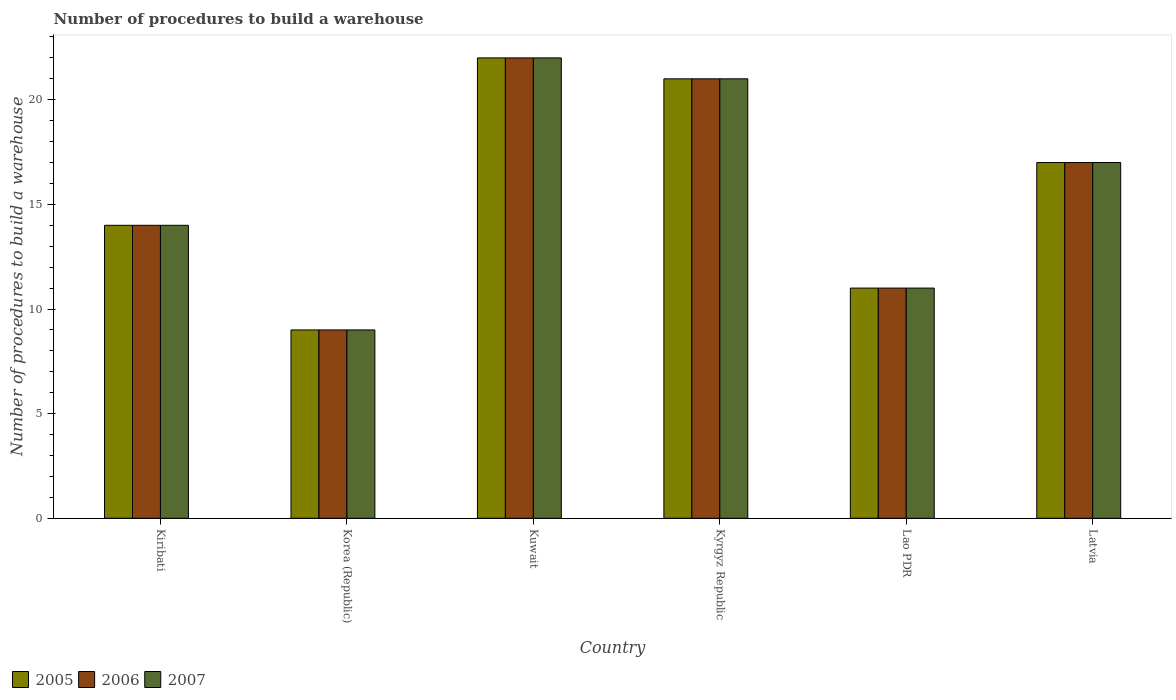Are the number of bars per tick equal to the number of legend labels?
Ensure brevity in your answer.  Yes. How many bars are there on the 6th tick from the left?
Your answer should be very brief. 3. How many bars are there on the 5th tick from the right?
Your answer should be compact. 3. What is the label of the 1st group of bars from the left?
Your answer should be very brief. Kiribati. In how many cases, is the number of bars for a given country not equal to the number of legend labels?
Make the answer very short. 0. In which country was the number of procedures to build a warehouse in in 2007 maximum?
Your response must be concise. Kuwait. What is the total number of procedures to build a warehouse in in 2007 in the graph?
Your answer should be compact. 94. What is the difference between the number of procedures to build a warehouse in in 2007 in Lao PDR and that in Latvia?
Ensure brevity in your answer.  -6. What is the average number of procedures to build a warehouse in in 2005 per country?
Offer a terse response. 15.67. In how many countries, is the number of procedures to build a warehouse in in 2006 greater than 4?
Offer a very short reply. 6. What is the ratio of the number of procedures to build a warehouse in in 2005 in Korea (Republic) to that in Latvia?
Provide a succinct answer. 0.53. Is the number of procedures to build a warehouse in in 2005 in Kuwait less than that in Kyrgyz Republic?
Provide a short and direct response. No. Is the difference between the number of procedures to build a warehouse in in 2006 in Kiribati and Latvia greater than the difference between the number of procedures to build a warehouse in in 2005 in Kiribati and Latvia?
Provide a succinct answer. No. What is the difference between the highest and the lowest number of procedures to build a warehouse in in 2005?
Your answer should be compact. 13. Is the sum of the number of procedures to build a warehouse in in 2007 in Korea (Republic) and Kyrgyz Republic greater than the maximum number of procedures to build a warehouse in in 2006 across all countries?
Your answer should be compact. Yes. What does the 1st bar from the right in Kuwait represents?
Offer a terse response. 2007. Are all the bars in the graph horizontal?
Keep it short and to the point. No. How many countries are there in the graph?
Provide a succinct answer. 6. Are the values on the major ticks of Y-axis written in scientific E-notation?
Keep it short and to the point. No. Does the graph contain any zero values?
Offer a terse response. No. What is the title of the graph?
Your answer should be compact. Number of procedures to build a warehouse. What is the label or title of the Y-axis?
Your answer should be compact. Number of procedures to build a warehouse. What is the Number of procedures to build a warehouse in 2007 in Kiribati?
Offer a very short reply. 14. What is the Number of procedures to build a warehouse in 2006 in Korea (Republic)?
Your response must be concise. 9. What is the Number of procedures to build a warehouse in 2006 in Kuwait?
Your answer should be compact. 22. What is the Number of procedures to build a warehouse in 2007 in Kuwait?
Give a very brief answer. 22. What is the Number of procedures to build a warehouse in 2005 in Kyrgyz Republic?
Keep it short and to the point. 21. What is the Number of procedures to build a warehouse in 2006 in Kyrgyz Republic?
Keep it short and to the point. 21. What is the Number of procedures to build a warehouse in 2005 in Lao PDR?
Give a very brief answer. 11. What is the Number of procedures to build a warehouse in 2005 in Latvia?
Your answer should be compact. 17. What is the Number of procedures to build a warehouse in 2006 in Latvia?
Your answer should be very brief. 17. What is the Number of procedures to build a warehouse in 2007 in Latvia?
Offer a terse response. 17. Across all countries, what is the maximum Number of procedures to build a warehouse of 2005?
Offer a very short reply. 22. Across all countries, what is the maximum Number of procedures to build a warehouse of 2006?
Your answer should be very brief. 22. Across all countries, what is the minimum Number of procedures to build a warehouse of 2005?
Offer a very short reply. 9. Across all countries, what is the minimum Number of procedures to build a warehouse in 2006?
Provide a succinct answer. 9. Across all countries, what is the minimum Number of procedures to build a warehouse of 2007?
Your answer should be very brief. 9. What is the total Number of procedures to build a warehouse in 2005 in the graph?
Provide a succinct answer. 94. What is the total Number of procedures to build a warehouse of 2006 in the graph?
Give a very brief answer. 94. What is the total Number of procedures to build a warehouse in 2007 in the graph?
Your response must be concise. 94. What is the difference between the Number of procedures to build a warehouse in 2005 in Kiribati and that in Korea (Republic)?
Your answer should be very brief. 5. What is the difference between the Number of procedures to build a warehouse in 2005 in Kiribati and that in Kuwait?
Offer a terse response. -8. What is the difference between the Number of procedures to build a warehouse in 2006 in Kiribati and that in Kuwait?
Give a very brief answer. -8. What is the difference between the Number of procedures to build a warehouse in 2007 in Kiribati and that in Kuwait?
Offer a very short reply. -8. What is the difference between the Number of procedures to build a warehouse of 2006 in Kiribati and that in Kyrgyz Republic?
Give a very brief answer. -7. What is the difference between the Number of procedures to build a warehouse of 2007 in Kiribati and that in Kyrgyz Republic?
Keep it short and to the point. -7. What is the difference between the Number of procedures to build a warehouse in 2005 in Kiribati and that in Lao PDR?
Your answer should be very brief. 3. What is the difference between the Number of procedures to build a warehouse in 2007 in Kiribati and that in Lao PDR?
Provide a succinct answer. 3. What is the difference between the Number of procedures to build a warehouse of 2005 in Kiribati and that in Latvia?
Your response must be concise. -3. What is the difference between the Number of procedures to build a warehouse of 2007 in Kiribati and that in Latvia?
Your response must be concise. -3. What is the difference between the Number of procedures to build a warehouse in 2007 in Korea (Republic) and that in Kuwait?
Provide a succinct answer. -13. What is the difference between the Number of procedures to build a warehouse of 2006 in Korea (Republic) and that in Kyrgyz Republic?
Your answer should be very brief. -12. What is the difference between the Number of procedures to build a warehouse in 2007 in Korea (Republic) and that in Kyrgyz Republic?
Your response must be concise. -12. What is the difference between the Number of procedures to build a warehouse in 2006 in Korea (Republic) and that in Lao PDR?
Your answer should be compact. -2. What is the difference between the Number of procedures to build a warehouse of 2007 in Korea (Republic) and that in Lao PDR?
Offer a terse response. -2. What is the difference between the Number of procedures to build a warehouse in 2006 in Kuwait and that in Kyrgyz Republic?
Offer a terse response. 1. What is the difference between the Number of procedures to build a warehouse in 2007 in Kuwait and that in Kyrgyz Republic?
Provide a succinct answer. 1. What is the difference between the Number of procedures to build a warehouse in 2005 in Kuwait and that in Lao PDR?
Make the answer very short. 11. What is the difference between the Number of procedures to build a warehouse of 2006 in Kuwait and that in Latvia?
Provide a short and direct response. 5. What is the difference between the Number of procedures to build a warehouse of 2007 in Kyrgyz Republic and that in Lao PDR?
Offer a very short reply. 10. What is the difference between the Number of procedures to build a warehouse in 2005 in Kyrgyz Republic and that in Latvia?
Your answer should be very brief. 4. What is the difference between the Number of procedures to build a warehouse in 2006 in Kyrgyz Republic and that in Latvia?
Offer a terse response. 4. What is the difference between the Number of procedures to build a warehouse of 2007 in Lao PDR and that in Latvia?
Offer a very short reply. -6. What is the difference between the Number of procedures to build a warehouse of 2005 in Kiribati and the Number of procedures to build a warehouse of 2006 in Korea (Republic)?
Your response must be concise. 5. What is the difference between the Number of procedures to build a warehouse in 2005 in Kiribati and the Number of procedures to build a warehouse in 2007 in Korea (Republic)?
Your answer should be compact. 5. What is the difference between the Number of procedures to build a warehouse in 2005 in Kiribati and the Number of procedures to build a warehouse in 2006 in Kuwait?
Make the answer very short. -8. What is the difference between the Number of procedures to build a warehouse of 2005 in Kiribati and the Number of procedures to build a warehouse of 2007 in Kuwait?
Make the answer very short. -8. What is the difference between the Number of procedures to build a warehouse of 2006 in Kiribati and the Number of procedures to build a warehouse of 2007 in Kuwait?
Keep it short and to the point. -8. What is the difference between the Number of procedures to build a warehouse in 2005 in Kiribati and the Number of procedures to build a warehouse in 2006 in Kyrgyz Republic?
Your answer should be compact. -7. What is the difference between the Number of procedures to build a warehouse in 2006 in Kiribati and the Number of procedures to build a warehouse in 2007 in Kyrgyz Republic?
Provide a short and direct response. -7. What is the difference between the Number of procedures to build a warehouse in 2005 in Kiribati and the Number of procedures to build a warehouse in 2006 in Lao PDR?
Provide a succinct answer. 3. What is the difference between the Number of procedures to build a warehouse in 2006 in Kiribati and the Number of procedures to build a warehouse in 2007 in Lao PDR?
Your answer should be very brief. 3. What is the difference between the Number of procedures to build a warehouse of 2005 in Kiribati and the Number of procedures to build a warehouse of 2006 in Latvia?
Provide a short and direct response. -3. What is the difference between the Number of procedures to build a warehouse in 2006 in Kiribati and the Number of procedures to build a warehouse in 2007 in Latvia?
Your response must be concise. -3. What is the difference between the Number of procedures to build a warehouse of 2005 in Korea (Republic) and the Number of procedures to build a warehouse of 2006 in Kuwait?
Your answer should be compact. -13. What is the difference between the Number of procedures to build a warehouse of 2005 in Korea (Republic) and the Number of procedures to build a warehouse of 2007 in Kuwait?
Offer a terse response. -13. What is the difference between the Number of procedures to build a warehouse of 2005 in Korea (Republic) and the Number of procedures to build a warehouse of 2007 in Kyrgyz Republic?
Give a very brief answer. -12. What is the difference between the Number of procedures to build a warehouse in 2005 in Korea (Republic) and the Number of procedures to build a warehouse in 2006 in Lao PDR?
Ensure brevity in your answer.  -2. What is the difference between the Number of procedures to build a warehouse in 2005 in Korea (Republic) and the Number of procedures to build a warehouse in 2007 in Lao PDR?
Give a very brief answer. -2. What is the difference between the Number of procedures to build a warehouse in 2005 in Kuwait and the Number of procedures to build a warehouse in 2006 in Kyrgyz Republic?
Offer a terse response. 1. What is the difference between the Number of procedures to build a warehouse of 2006 in Kuwait and the Number of procedures to build a warehouse of 2007 in Kyrgyz Republic?
Make the answer very short. 1. What is the difference between the Number of procedures to build a warehouse in 2005 in Kuwait and the Number of procedures to build a warehouse in 2006 in Lao PDR?
Keep it short and to the point. 11. What is the difference between the Number of procedures to build a warehouse in 2005 in Kuwait and the Number of procedures to build a warehouse in 2007 in Lao PDR?
Your answer should be compact. 11. What is the difference between the Number of procedures to build a warehouse in 2005 in Kuwait and the Number of procedures to build a warehouse in 2007 in Latvia?
Your answer should be compact. 5. What is the difference between the Number of procedures to build a warehouse in 2006 in Kuwait and the Number of procedures to build a warehouse in 2007 in Latvia?
Make the answer very short. 5. What is the average Number of procedures to build a warehouse in 2005 per country?
Your response must be concise. 15.67. What is the average Number of procedures to build a warehouse of 2006 per country?
Your response must be concise. 15.67. What is the average Number of procedures to build a warehouse in 2007 per country?
Provide a short and direct response. 15.67. What is the difference between the Number of procedures to build a warehouse in 2005 and Number of procedures to build a warehouse in 2006 in Kiribati?
Your response must be concise. 0. What is the difference between the Number of procedures to build a warehouse in 2005 and Number of procedures to build a warehouse in 2007 in Korea (Republic)?
Keep it short and to the point. 0. What is the difference between the Number of procedures to build a warehouse in 2006 and Number of procedures to build a warehouse in 2007 in Korea (Republic)?
Keep it short and to the point. 0. What is the difference between the Number of procedures to build a warehouse of 2005 and Number of procedures to build a warehouse of 2007 in Kuwait?
Ensure brevity in your answer.  0. What is the difference between the Number of procedures to build a warehouse in 2005 and Number of procedures to build a warehouse in 2006 in Kyrgyz Republic?
Provide a short and direct response. 0. What is the difference between the Number of procedures to build a warehouse in 2006 and Number of procedures to build a warehouse in 2007 in Lao PDR?
Offer a terse response. 0. What is the ratio of the Number of procedures to build a warehouse of 2005 in Kiribati to that in Korea (Republic)?
Provide a succinct answer. 1.56. What is the ratio of the Number of procedures to build a warehouse in 2006 in Kiribati to that in Korea (Republic)?
Offer a terse response. 1.56. What is the ratio of the Number of procedures to build a warehouse of 2007 in Kiribati to that in Korea (Republic)?
Provide a succinct answer. 1.56. What is the ratio of the Number of procedures to build a warehouse of 2005 in Kiribati to that in Kuwait?
Offer a very short reply. 0.64. What is the ratio of the Number of procedures to build a warehouse in 2006 in Kiribati to that in Kuwait?
Give a very brief answer. 0.64. What is the ratio of the Number of procedures to build a warehouse of 2007 in Kiribati to that in Kuwait?
Keep it short and to the point. 0.64. What is the ratio of the Number of procedures to build a warehouse in 2005 in Kiribati to that in Kyrgyz Republic?
Your response must be concise. 0.67. What is the ratio of the Number of procedures to build a warehouse in 2006 in Kiribati to that in Kyrgyz Republic?
Give a very brief answer. 0.67. What is the ratio of the Number of procedures to build a warehouse in 2007 in Kiribati to that in Kyrgyz Republic?
Offer a very short reply. 0.67. What is the ratio of the Number of procedures to build a warehouse of 2005 in Kiribati to that in Lao PDR?
Provide a short and direct response. 1.27. What is the ratio of the Number of procedures to build a warehouse of 2006 in Kiribati to that in Lao PDR?
Offer a very short reply. 1.27. What is the ratio of the Number of procedures to build a warehouse of 2007 in Kiribati to that in Lao PDR?
Ensure brevity in your answer.  1.27. What is the ratio of the Number of procedures to build a warehouse of 2005 in Kiribati to that in Latvia?
Give a very brief answer. 0.82. What is the ratio of the Number of procedures to build a warehouse of 2006 in Kiribati to that in Latvia?
Keep it short and to the point. 0.82. What is the ratio of the Number of procedures to build a warehouse in 2007 in Kiribati to that in Latvia?
Your answer should be very brief. 0.82. What is the ratio of the Number of procedures to build a warehouse in 2005 in Korea (Republic) to that in Kuwait?
Your response must be concise. 0.41. What is the ratio of the Number of procedures to build a warehouse in 2006 in Korea (Republic) to that in Kuwait?
Your response must be concise. 0.41. What is the ratio of the Number of procedures to build a warehouse in 2007 in Korea (Republic) to that in Kuwait?
Offer a terse response. 0.41. What is the ratio of the Number of procedures to build a warehouse in 2005 in Korea (Republic) to that in Kyrgyz Republic?
Give a very brief answer. 0.43. What is the ratio of the Number of procedures to build a warehouse in 2006 in Korea (Republic) to that in Kyrgyz Republic?
Ensure brevity in your answer.  0.43. What is the ratio of the Number of procedures to build a warehouse in 2007 in Korea (Republic) to that in Kyrgyz Republic?
Make the answer very short. 0.43. What is the ratio of the Number of procedures to build a warehouse in 2005 in Korea (Republic) to that in Lao PDR?
Offer a very short reply. 0.82. What is the ratio of the Number of procedures to build a warehouse of 2006 in Korea (Republic) to that in Lao PDR?
Your answer should be compact. 0.82. What is the ratio of the Number of procedures to build a warehouse of 2007 in Korea (Republic) to that in Lao PDR?
Your answer should be compact. 0.82. What is the ratio of the Number of procedures to build a warehouse of 2005 in Korea (Republic) to that in Latvia?
Your answer should be very brief. 0.53. What is the ratio of the Number of procedures to build a warehouse in 2006 in Korea (Republic) to that in Latvia?
Your answer should be very brief. 0.53. What is the ratio of the Number of procedures to build a warehouse in 2007 in Korea (Republic) to that in Latvia?
Your answer should be very brief. 0.53. What is the ratio of the Number of procedures to build a warehouse in 2005 in Kuwait to that in Kyrgyz Republic?
Offer a very short reply. 1.05. What is the ratio of the Number of procedures to build a warehouse of 2006 in Kuwait to that in Kyrgyz Republic?
Your answer should be compact. 1.05. What is the ratio of the Number of procedures to build a warehouse in 2007 in Kuwait to that in Kyrgyz Republic?
Offer a terse response. 1.05. What is the ratio of the Number of procedures to build a warehouse of 2005 in Kuwait to that in Lao PDR?
Offer a very short reply. 2. What is the ratio of the Number of procedures to build a warehouse in 2005 in Kuwait to that in Latvia?
Your response must be concise. 1.29. What is the ratio of the Number of procedures to build a warehouse in 2006 in Kuwait to that in Latvia?
Keep it short and to the point. 1.29. What is the ratio of the Number of procedures to build a warehouse in 2007 in Kuwait to that in Latvia?
Keep it short and to the point. 1.29. What is the ratio of the Number of procedures to build a warehouse in 2005 in Kyrgyz Republic to that in Lao PDR?
Your answer should be compact. 1.91. What is the ratio of the Number of procedures to build a warehouse in 2006 in Kyrgyz Republic to that in Lao PDR?
Your response must be concise. 1.91. What is the ratio of the Number of procedures to build a warehouse in 2007 in Kyrgyz Republic to that in Lao PDR?
Give a very brief answer. 1.91. What is the ratio of the Number of procedures to build a warehouse of 2005 in Kyrgyz Republic to that in Latvia?
Give a very brief answer. 1.24. What is the ratio of the Number of procedures to build a warehouse of 2006 in Kyrgyz Republic to that in Latvia?
Offer a very short reply. 1.24. What is the ratio of the Number of procedures to build a warehouse in 2007 in Kyrgyz Republic to that in Latvia?
Make the answer very short. 1.24. What is the ratio of the Number of procedures to build a warehouse of 2005 in Lao PDR to that in Latvia?
Give a very brief answer. 0.65. What is the ratio of the Number of procedures to build a warehouse of 2006 in Lao PDR to that in Latvia?
Give a very brief answer. 0.65. What is the ratio of the Number of procedures to build a warehouse of 2007 in Lao PDR to that in Latvia?
Your answer should be compact. 0.65. What is the difference between the highest and the second highest Number of procedures to build a warehouse of 2005?
Make the answer very short. 1. What is the difference between the highest and the second highest Number of procedures to build a warehouse of 2006?
Ensure brevity in your answer.  1. What is the difference between the highest and the second highest Number of procedures to build a warehouse of 2007?
Keep it short and to the point. 1. What is the difference between the highest and the lowest Number of procedures to build a warehouse in 2005?
Ensure brevity in your answer.  13. 